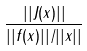<formula> <loc_0><loc_0><loc_500><loc_500>\frac { | | J ( x ) | | } { | | f ( x ) | | / | | x | | }</formula> 